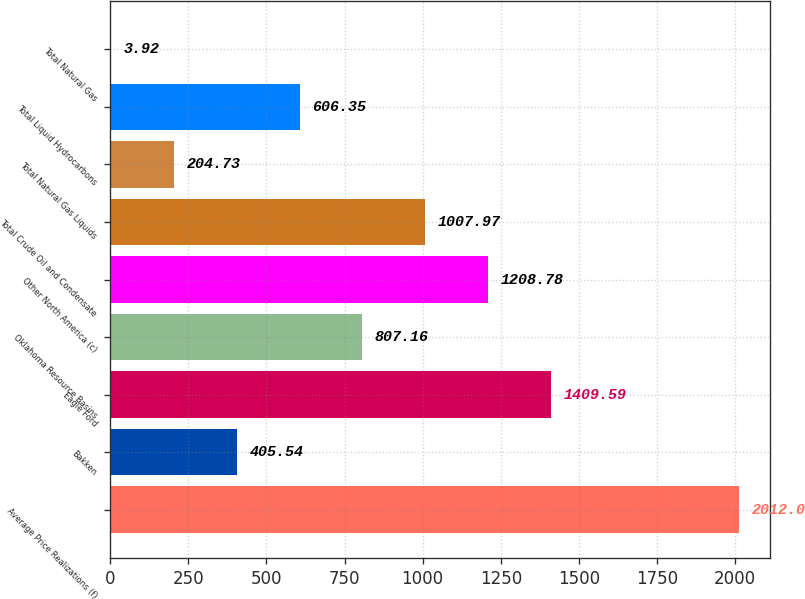Convert chart. <chart><loc_0><loc_0><loc_500><loc_500><bar_chart><fcel>Average Price Realizations (f)<fcel>Bakken<fcel>Eagle Ford<fcel>Oklahoma Resource Basins<fcel>Other North America (c)<fcel>Total Crude Oil and Condensate<fcel>Total Natural Gas Liquids<fcel>Total Liquid Hydrocarbons<fcel>Total Natural Gas<nl><fcel>2012<fcel>405.54<fcel>1409.59<fcel>807.16<fcel>1208.78<fcel>1007.97<fcel>204.73<fcel>606.35<fcel>3.92<nl></chart> 